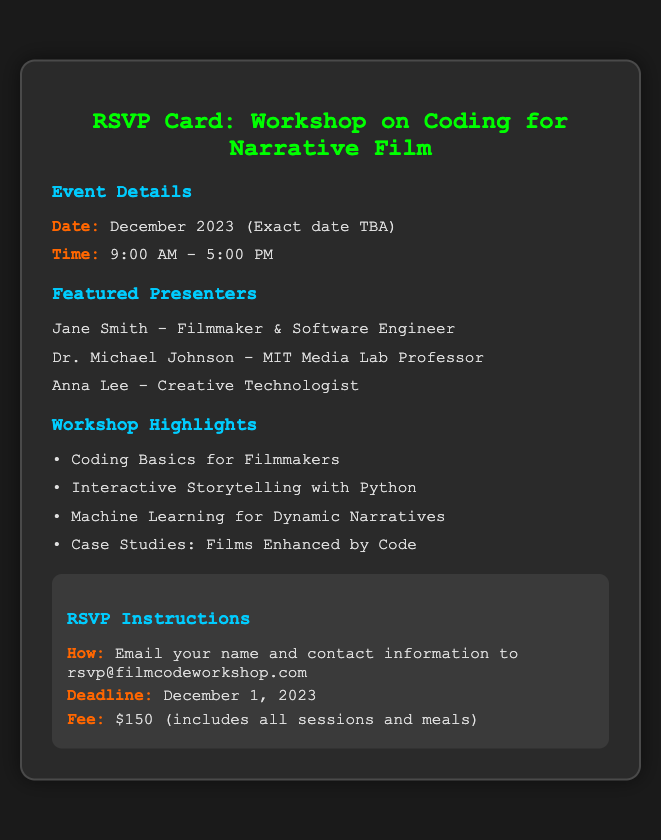What is the date of the workshop? The document states that the exact date is TBA but will occur in December 2023.
Answer: December 2023 (Exact date TBA) What is included in the fee? The fee information indicates that it includes all sessions and meals.
Answer: All sessions and meals Who is one of the featured presenters? The document lists three presenters, one of whom is Jane Smith.
Answer: Jane Smith What is the deadline for RSVP? The RSVP instructions specify that the deadline is December 1, 2023.
Answer: December 1, 2023 What is the workshop's starting time? The document provides the starting time for the workshop as 9:00 AM.
Answer: 9:00 AM How many workshop highlights are mentioned? There are four interactive coding topics listed in the workshop highlights.
Answer: Four What should be included in the RSVP email? The document mentions that the RSVP email should contain the sender's name and contact information.
Answer: Name and contact information What is the location of the event? The document does not specify a location for the workshop.
Answer: Not specified What is the focus of the workshop? The overall theme of the workshop is coding for narrative film, which encompasses various aspects of filmmaking and technology.
Answer: Coding for narrative film 